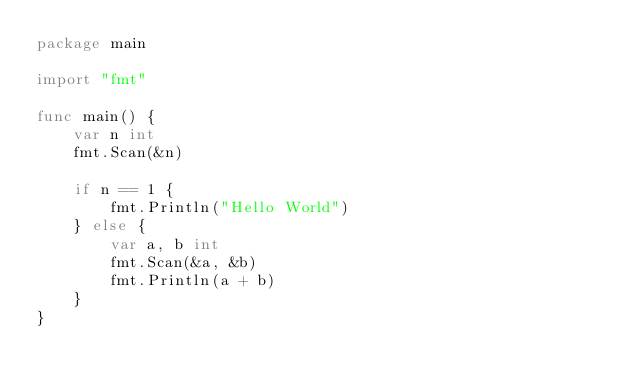Convert code to text. <code><loc_0><loc_0><loc_500><loc_500><_Go_>package main

import "fmt"

func main() {
	var n int
	fmt.Scan(&n)

	if n == 1 {
		fmt.Println("Hello World")
	} else {
		var a, b int
		fmt.Scan(&a, &b)
		fmt.Println(a + b)
	}
}
</code> 